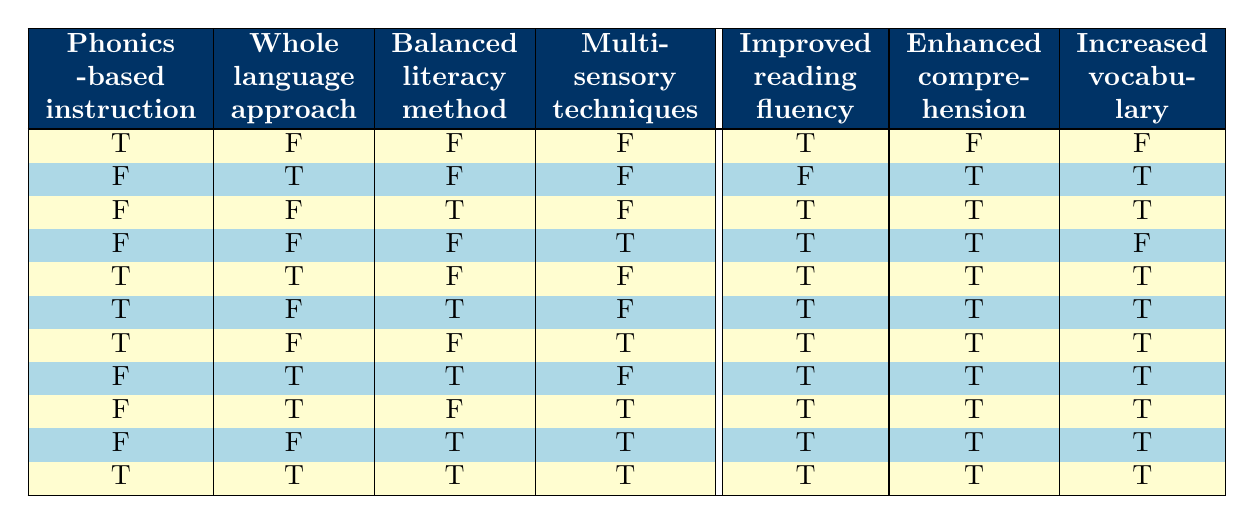What instruction method resulted in improved reading fluency? According to the table, the only method that resulted in improved reading fluency is the Phonics-based instruction as seen in the first, fifth, sixth, seventh, tenth rows.
Answer: Phonics-based instruction Did the Balanced literacy method enhance comprehension? Looking at the table, the Balanced literacy method only produced enhanced comprehension in row three, where it was true. For all other rows, either Phonics or Whole language approaches were responsible for enhancing comprehension.
Answer: Yes Which methods were associated with increased vocabulary? The two methods that led to an increase in vocabulary are the Whole language approach and Balanced literacy method. They are shown as true in rows two, three, eight, and nine.
Answer: Whole language approach and Balanced literacy method How many instruction methods resulted in all three outcomes being true? By reviewing the table, the only instruction method that corresponds with all three outcomes being true is shown in the last row where all methods are true, leading to improved fluency, enhanced comprehension, and increased vocabulary.
Answer: One method Is the Multisensory technique effective in improving reading fluency? In the provided data, the Multisensory technique resulted in improved reading fluency only in rows four, seven, nine, and ten. Therefore, it can be considered effective for reading fluency.
Answer: Yes What is the average effectiveness of all methods in enhancing comprehension? By analyzing the table, we count the occurrences of enhanced comprehension being true (which happens in rows two, three, four, five, six, seven, eight, nine, ten), giving a total of eight out of ten methods showing improvement in comprehension, resulting in an average effectiveness of 80 percent.
Answer: 80 percent Do any methods produce improved reading fluency without enhancing comprehension? From the table, the list shows that only the Phonics-based instruction from the first row records improved fluency while not enhancing comprehension, resulting in one method fulfilling this condition.
Answer: Yes Which two methods together enhance comprehension and increase vocabulary? Referring to the table, the combination of the Whole language approach (which enhances comprehension and vocabulary) and the Balanced literacy method (which also enhances comprehension and vocabulary), occurs together in the data multiple times (rows five, eight, nine, and ten).
Answer: Whole language approach and Balanced literacy method 